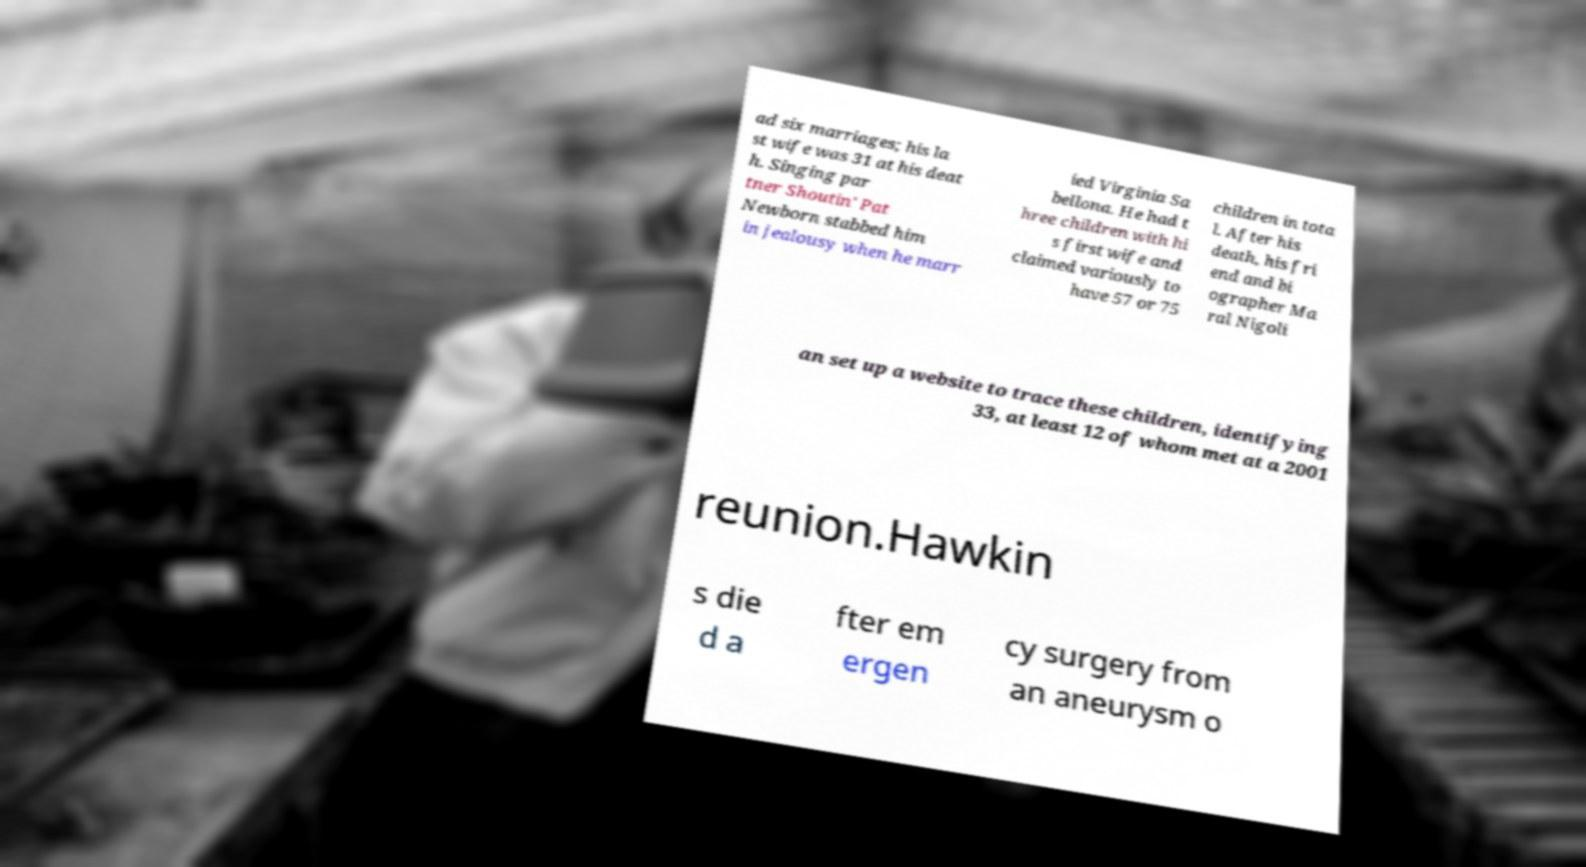Please identify and transcribe the text found in this image. ad six marriages; his la st wife was 31 at his deat h. Singing par tner Shoutin' Pat Newborn stabbed him in jealousy when he marr ied Virginia Sa bellona. He had t hree children with hi s first wife and claimed variously to have 57 or 75 children in tota l. After his death, his fri end and bi ographer Ma ral Nigoli an set up a website to trace these children, identifying 33, at least 12 of whom met at a 2001 reunion.Hawkin s die d a fter em ergen cy surgery from an aneurysm o 